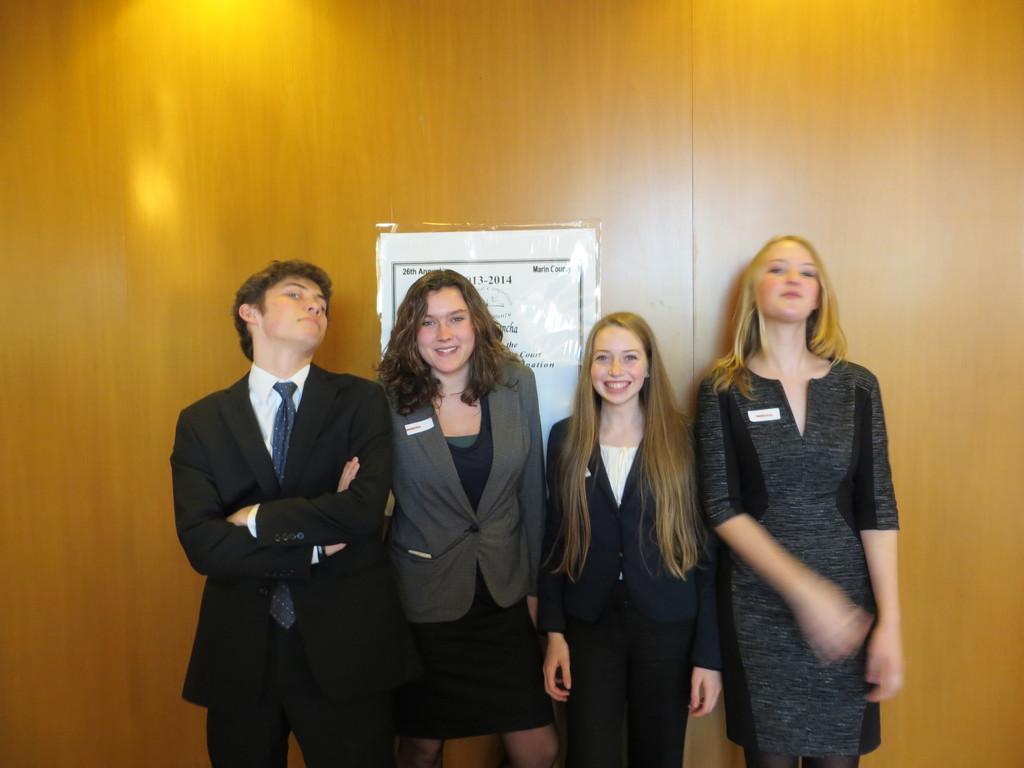In one or two sentences, can you explain what this image depicts? In this image there are four people who are standing and smiling and in the background there is a wooden wall, on the wall there is one poster. 